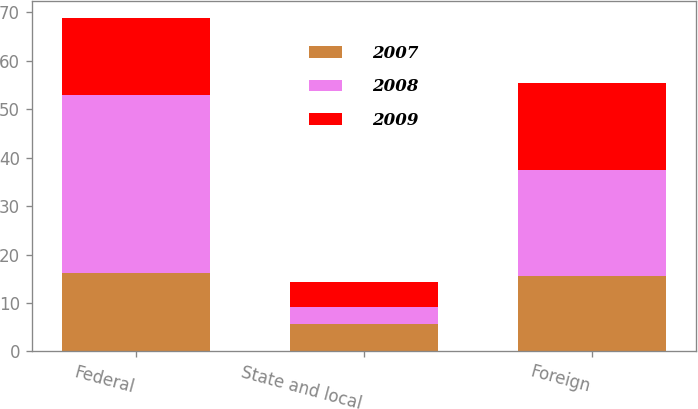Convert chart to OTSL. <chart><loc_0><loc_0><loc_500><loc_500><stacked_bar_chart><ecel><fcel>Federal<fcel>State and local<fcel>Foreign<nl><fcel>2007<fcel>16.1<fcel>5.7<fcel>15.6<nl><fcel>2008<fcel>36.9<fcel>3.5<fcel>21.8<nl><fcel>2009<fcel>15.85<fcel>5.1<fcel>18<nl></chart> 